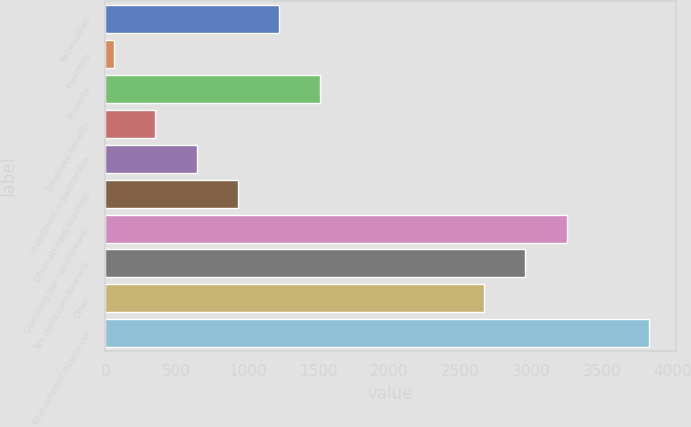Convert chart. <chart><loc_0><loc_0><loc_500><loc_500><bar_chart><fcel>Receivables<fcel>Inventory<fcel>Property<fcel>Employee benefits<fcel>Investment in partnership<fcel>Other accrued expenses<fcel>Operating loss carryforwards<fcel>Tax credit carryforwards<fcel>Other<fcel>Total deferred income tax<nl><fcel>1222.6<fcel>63<fcel>1512.5<fcel>352.9<fcel>642.8<fcel>932.7<fcel>3251.9<fcel>2962<fcel>2672.1<fcel>3831.7<nl></chart> 